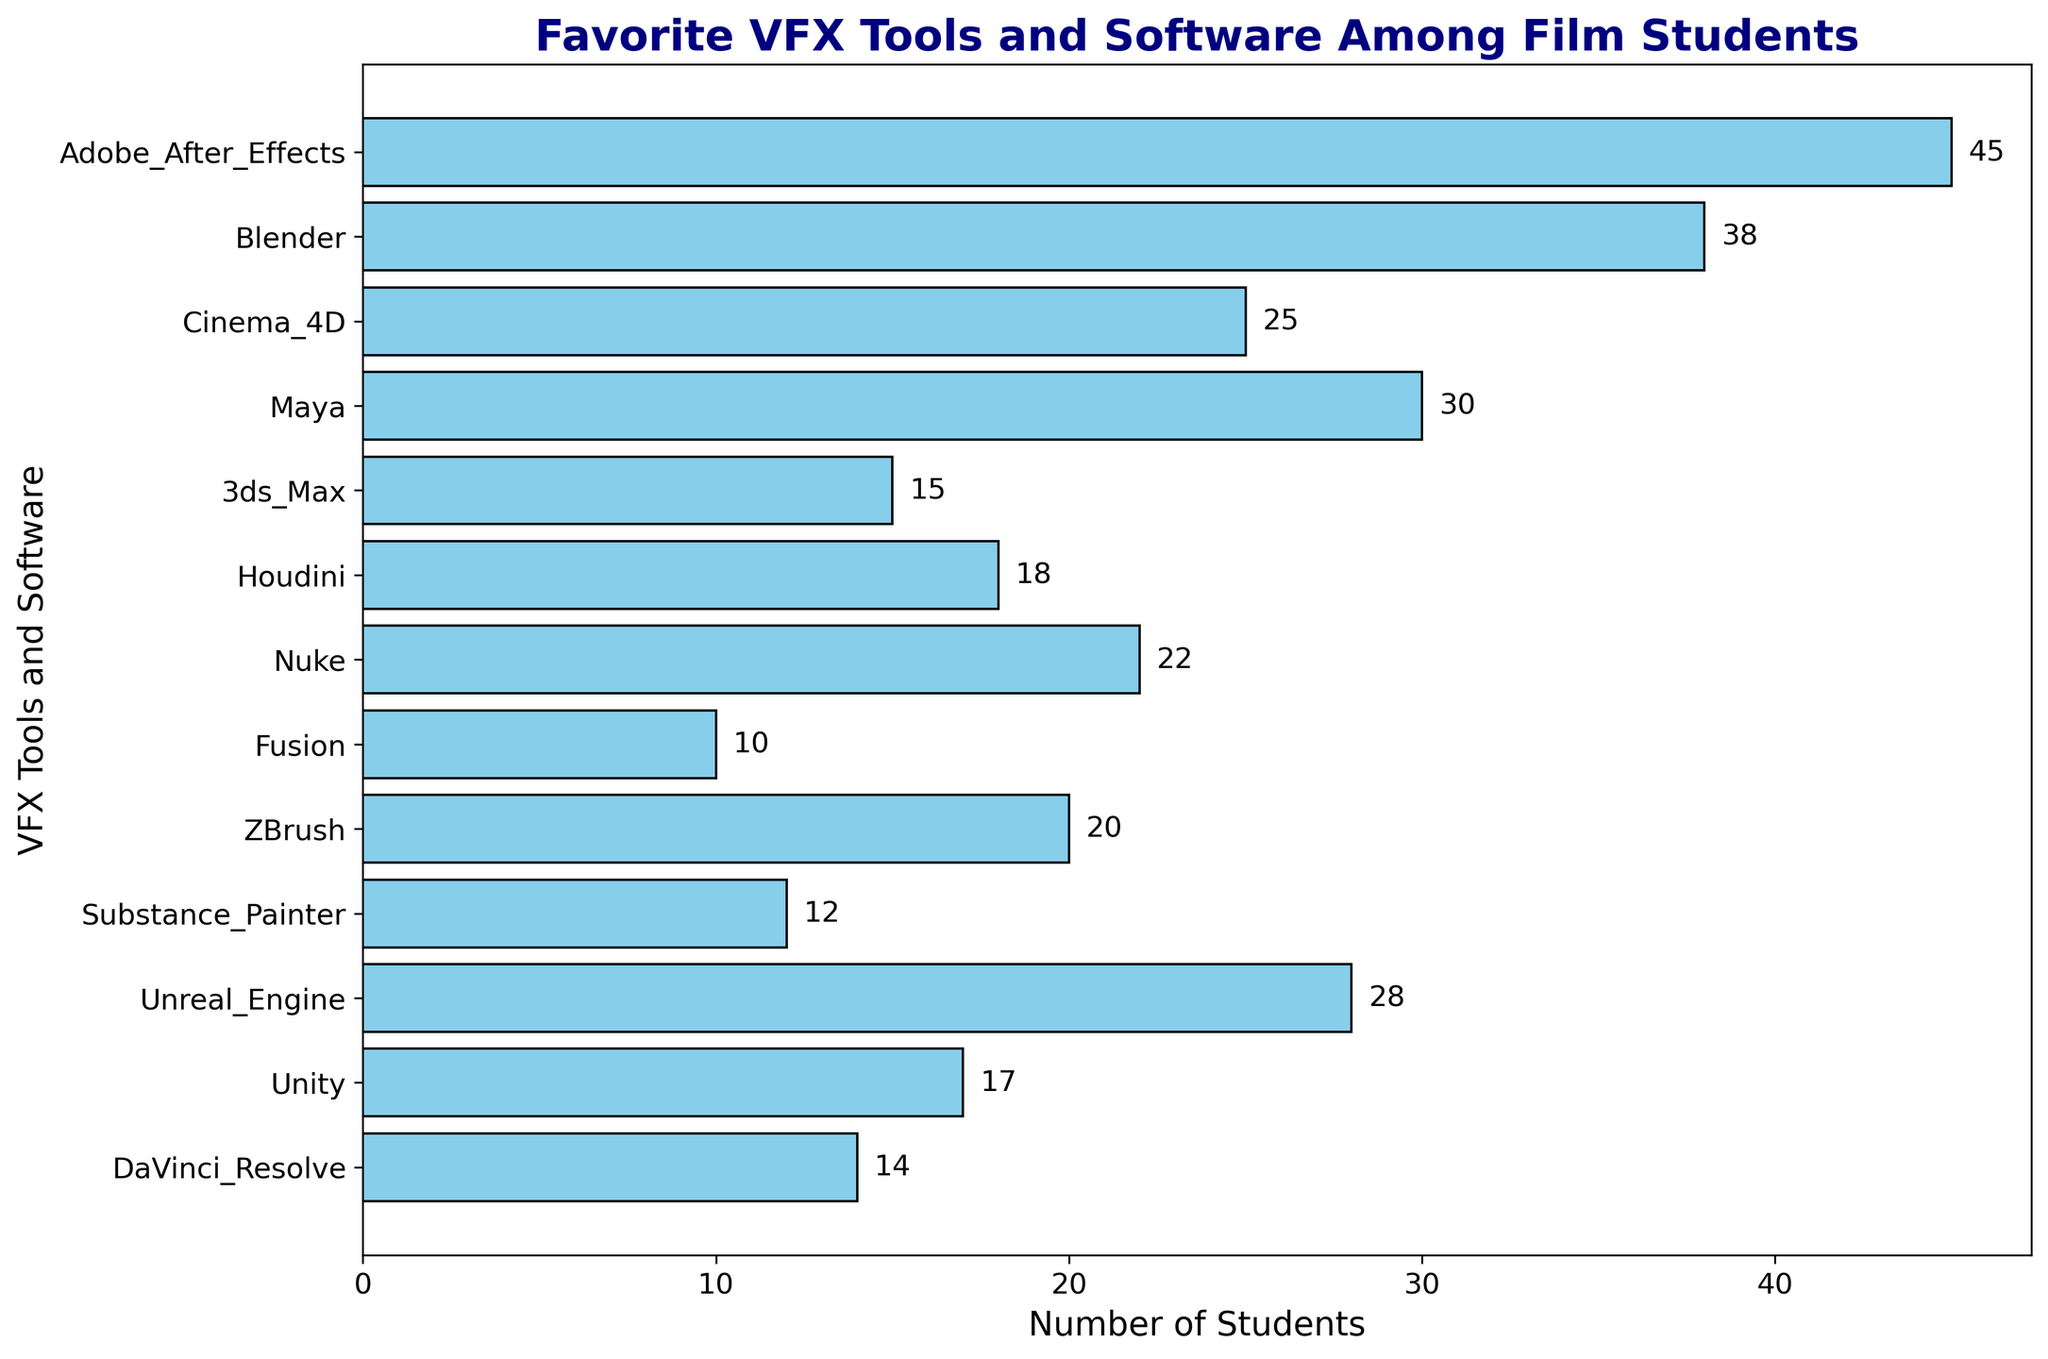Which VFX tool is the most popular among film students? To find the most popular VFX tool, observe the tool with the largest horizontal bar. Looking at the figure, Adobe After Effects has the longest bar.
Answer: Adobe After Effects How many more students prefer Adobe After Effects compared to Blender? Adobe After Effects is favored by 45 students, while Blender is favored by 38 students. Subtract the number of students who prefer Blender from those who prefer Adobe After Effects: 45 - 38.
Answer: 7 What's the average number of students using Blender, Maya, and Unreal Engine? Add the number of students using Blender (38), Maya (30), and Unreal Engine (28), then divide by the number of tools (3): (38 + 30 + 28) / 3.
Answer: 32 Which VFX tool has the fewest users? To determine the VFX tool with the fewest users, look for the shortest bar in the figure. Fusion is the tool with the shortest bar.
Answer: Fusion How does the number of students preferring Cinema 4D compare to those preferring Nuke? Cinema 4D is preferred by 25 students, and Nuke by 22 students. Subtract the number of students who prefer Nuke from those who prefer Cinema 4D: 25 - 22.
Answer: 3 What's the total number of students using Houdini and Unity? Add the number of students using Houdini (18) and Unity (17): 18 + 17.
Answer: 35 Is the number of students using 3ds Max greater than, less than, or equal to the number of students using DaVinci Resolve? The number of students using 3ds Max is 15, and DaVinci Resolve is 14. Since 15 is greater than 14, 3ds Max has more users.
Answer: greater than Which tool has more students using it: Substance Painter or ZBrush? Substance Painter is used by 12 students, while ZBrush is used by 20 students. Since 20 is greater than 12, ZBrush has more students using it.
Answer: ZBrush How many students in total prefer Cinema 4D, Houdini, and ZBrush? Add the number of students using Cinema 4D (25), Houdini (18), and ZBrush (20): 25 + 18 + 20.
Answer: 63 What's the difference in the number of students between the most preferred tool and the least preferred tool? The most preferred tool is Adobe After Effects with 45 students, and the least preferred tool is Fusion with 10 students. Subtract the number of students using Fusion from those using Adobe After Effects: 45 - 10.
Answer: 35 